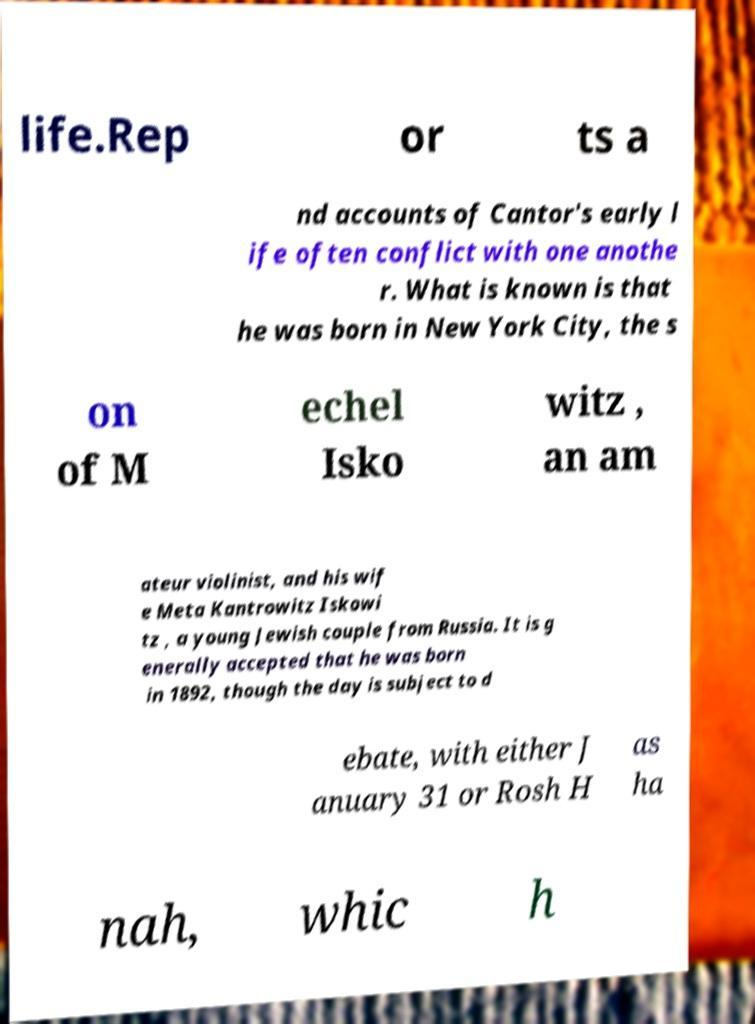Can you read and provide the text displayed in the image?This photo seems to have some interesting text. Can you extract and type it out for me? life.Rep or ts a nd accounts of Cantor's early l ife often conflict with one anothe r. What is known is that he was born in New York City, the s on of M echel Isko witz , an am ateur violinist, and his wif e Meta Kantrowitz Iskowi tz , a young Jewish couple from Russia. It is g enerally accepted that he was born in 1892, though the day is subject to d ebate, with either J anuary 31 or Rosh H as ha nah, whic h 